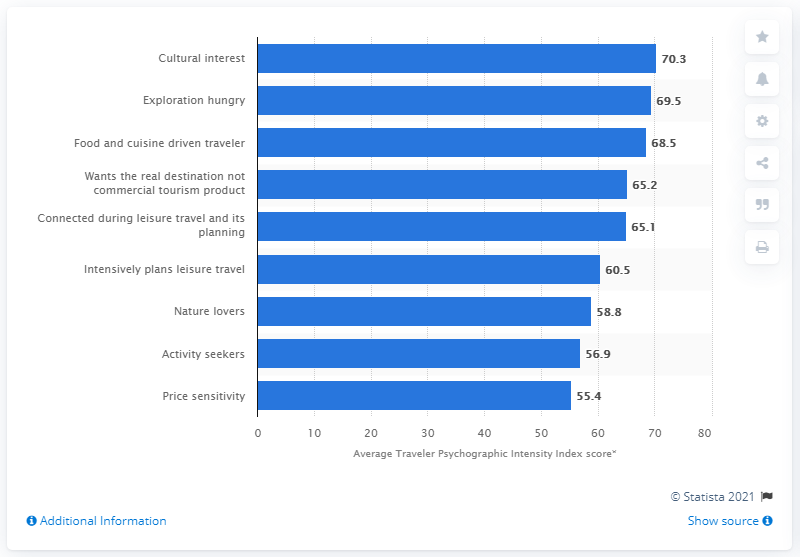Outline some significant characteristics in this image. The average score for the Traveler Psychographic Intensity Index was 70.3. 